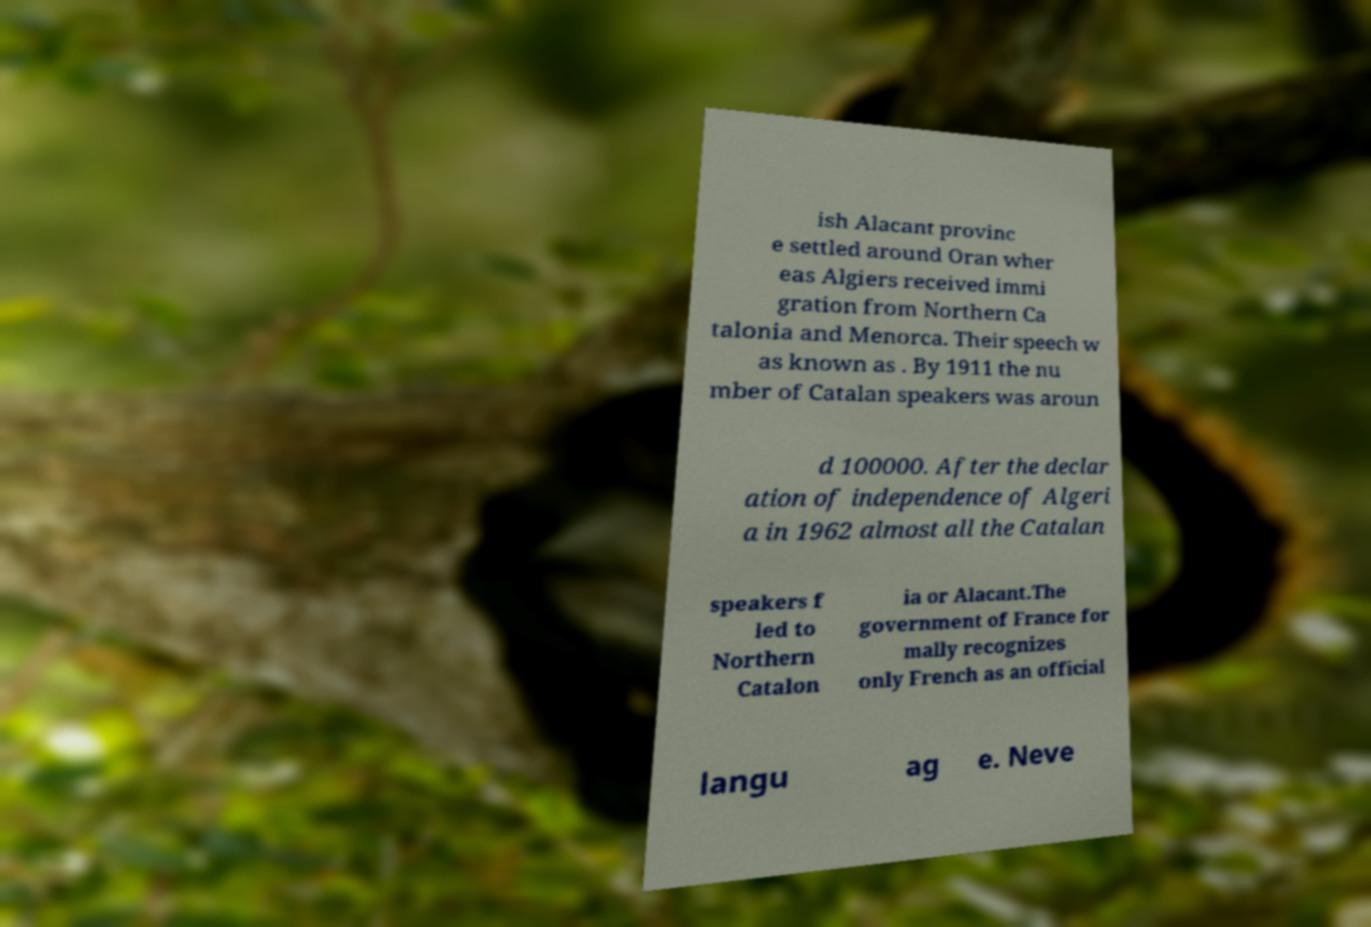What messages or text are displayed in this image? I need them in a readable, typed format. ish Alacant provinc e settled around Oran wher eas Algiers received immi gration from Northern Ca talonia and Menorca. Their speech w as known as . By 1911 the nu mber of Catalan speakers was aroun d 100000. After the declar ation of independence of Algeri a in 1962 almost all the Catalan speakers f led to Northern Catalon ia or Alacant.The government of France for mally recognizes only French as an official langu ag e. Neve 